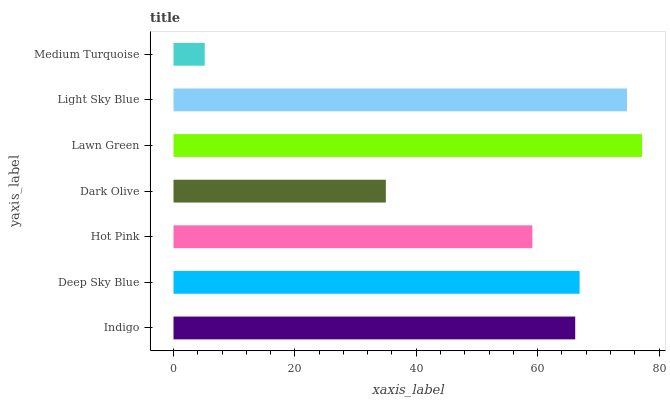Is Medium Turquoise the minimum?
Answer yes or no. Yes. Is Lawn Green the maximum?
Answer yes or no. Yes. Is Deep Sky Blue the minimum?
Answer yes or no. No. Is Deep Sky Blue the maximum?
Answer yes or no. No. Is Deep Sky Blue greater than Indigo?
Answer yes or no. Yes. Is Indigo less than Deep Sky Blue?
Answer yes or no. Yes. Is Indigo greater than Deep Sky Blue?
Answer yes or no. No. Is Deep Sky Blue less than Indigo?
Answer yes or no. No. Is Indigo the high median?
Answer yes or no. Yes. Is Indigo the low median?
Answer yes or no. Yes. Is Medium Turquoise the high median?
Answer yes or no. No. Is Dark Olive the low median?
Answer yes or no. No. 